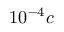Convert formula to latex. <formula><loc_0><loc_0><loc_500><loc_500>1 0 ^ { - 4 } c</formula> 